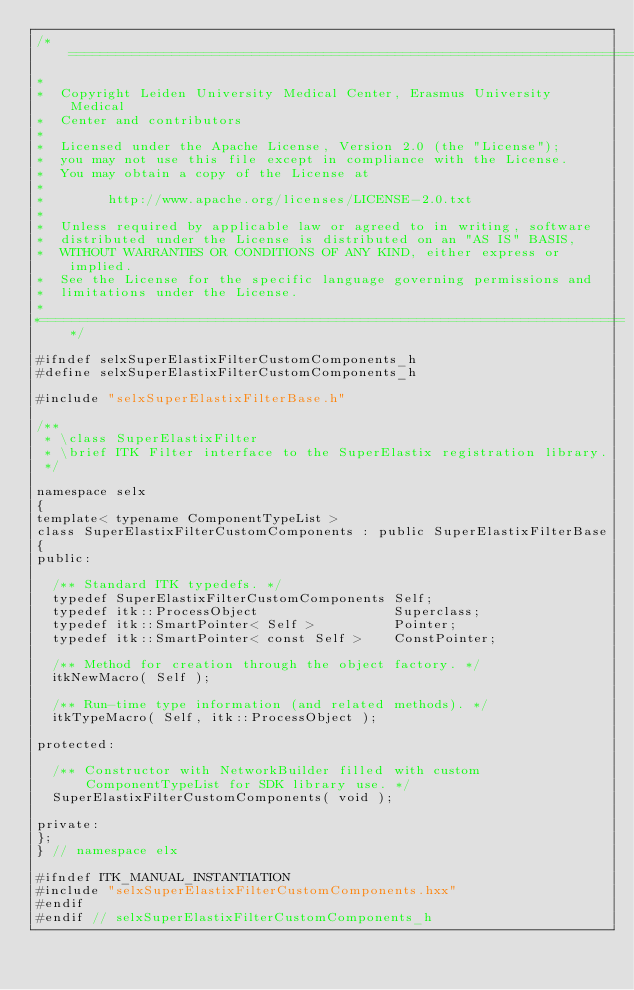<code> <loc_0><loc_0><loc_500><loc_500><_C_>/*=========================================================================
*
*  Copyright Leiden University Medical Center, Erasmus University Medical
*  Center and contributors
*
*  Licensed under the Apache License, Version 2.0 (the "License");
*  you may not use this file except in compliance with the License.
*  You may obtain a copy of the License at
*
*        http://www.apache.org/licenses/LICENSE-2.0.txt
*
*  Unless required by applicable law or agreed to in writing, software
*  distributed under the License is distributed on an "AS IS" BASIS,
*  WITHOUT WARRANTIES OR CONDITIONS OF ANY KIND, either express or implied.
*  See the License for the specific language governing permissions and
*  limitations under the License.
*
*=========================================================================*/

#ifndef selxSuperElastixFilterCustomComponents_h
#define selxSuperElastixFilterCustomComponents_h

#include "selxSuperElastixFilterBase.h"

/**
 * \class SuperElastixFilter
 * \brief ITK Filter interface to the SuperElastix registration library.
 */

namespace selx
{
template< typename ComponentTypeList >
class SuperElastixFilterCustomComponents : public SuperElastixFilterBase
{
public:

  /** Standard ITK typedefs. */
  typedef SuperElastixFilterCustomComponents Self;
  typedef itk::ProcessObject                 Superclass;
  typedef itk::SmartPointer< Self >          Pointer;
  typedef itk::SmartPointer< const Self >    ConstPointer;

  /** Method for creation through the object factory. */
  itkNewMacro( Self );

  /** Run-time type information (and related methods). */
  itkTypeMacro( Self, itk::ProcessObject );

protected:

  /** Constructor with NetworkBuilder filled with custom ComponentTypeList for SDK library use. */
  SuperElastixFilterCustomComponents( void );

private:
};
} // namespace elx

#ifndef ITK_MANUAL_INSTANTIATION
#include "selxSuperElastixFilterCustomComponents.hxx"
#endif
#endif // selxSuperElastixFilterCustomComponents_h
</code> 